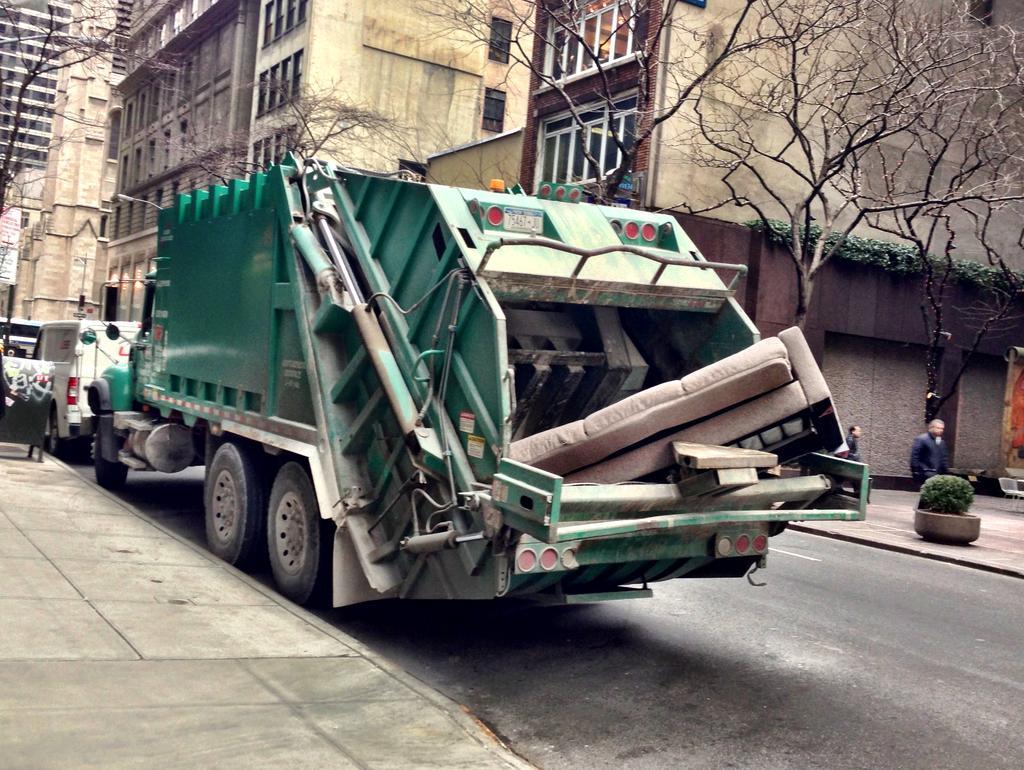Please provide a concise description of this image. In this image in the center there are vehicles. In the background there are buildings, trees, and on the right side there are persons. On the left side there is a person standing on the footpath. 